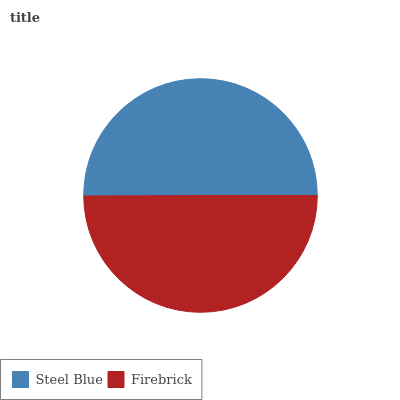Is Firebrick the minimum?
Answer yes or no. Yes. Is Steel Blue the maximum?
Answer yes or no. Yes. Is Firebrick the maximum?
Answer yes or no. No. Is Steel Blue greater than Firebrick?
Answer yes or no. Yes. Is Firebrick less than Steel Blue?
Answer yes or no. Yes. Is Firebrick greater than Steel Blue?
Answer yes or no. No. Is Steel Blue less than Firebrick?
Answer yes or no. No. Is Steel Blue the high median?
Answer yes or no. Yes. Is Firebrick the low median?
Answer yes or no. Yes. Is Firebrick the high median?
Answer yes or no. No. Is Steel Blue the low median?
Answer yes or no. No. 